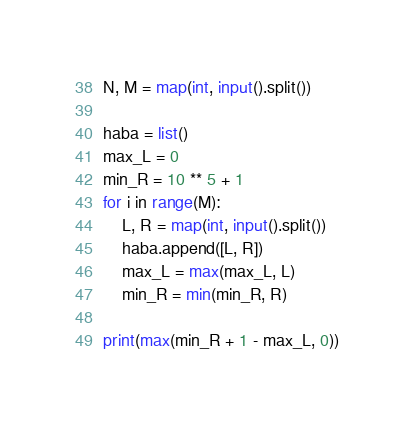<code> <loc_0><loc_0><loc_500><loc_500><_Python_>N, M = map(int, input().split())

haba = list()
max_L = 0
min_R = 10 ** 5 + 1
for i in range(M):
    L, R = map(int, input().split())
    haba.append([L, R])
    max_L = max(max_L, L)
    min_R = min(min_R, R)

print(max(min_R + 1 - max_L, 0))</code> 